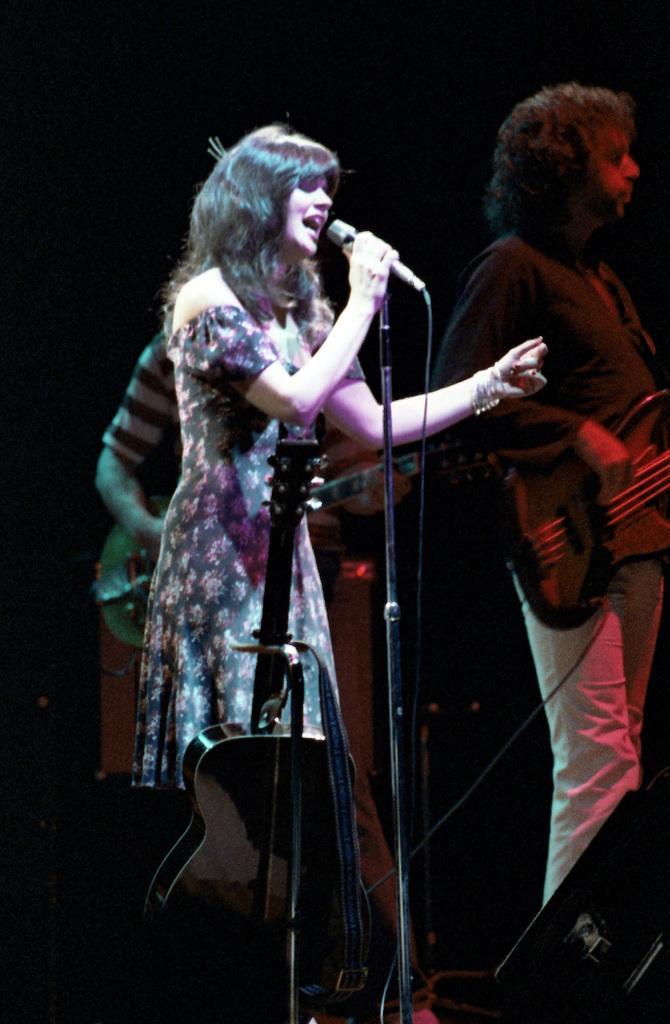Please provide a concise description of this image. There are three persons standing on a stage. They are playing a musical instruments. 